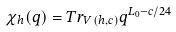<formula> <loc_0><loc_0><loc_500><loc_500>\chi _ { h } ( q ) = T r _ { V ( h , c ) } q ^ { L _ { 0 } - c / 2 4 }</formula> 